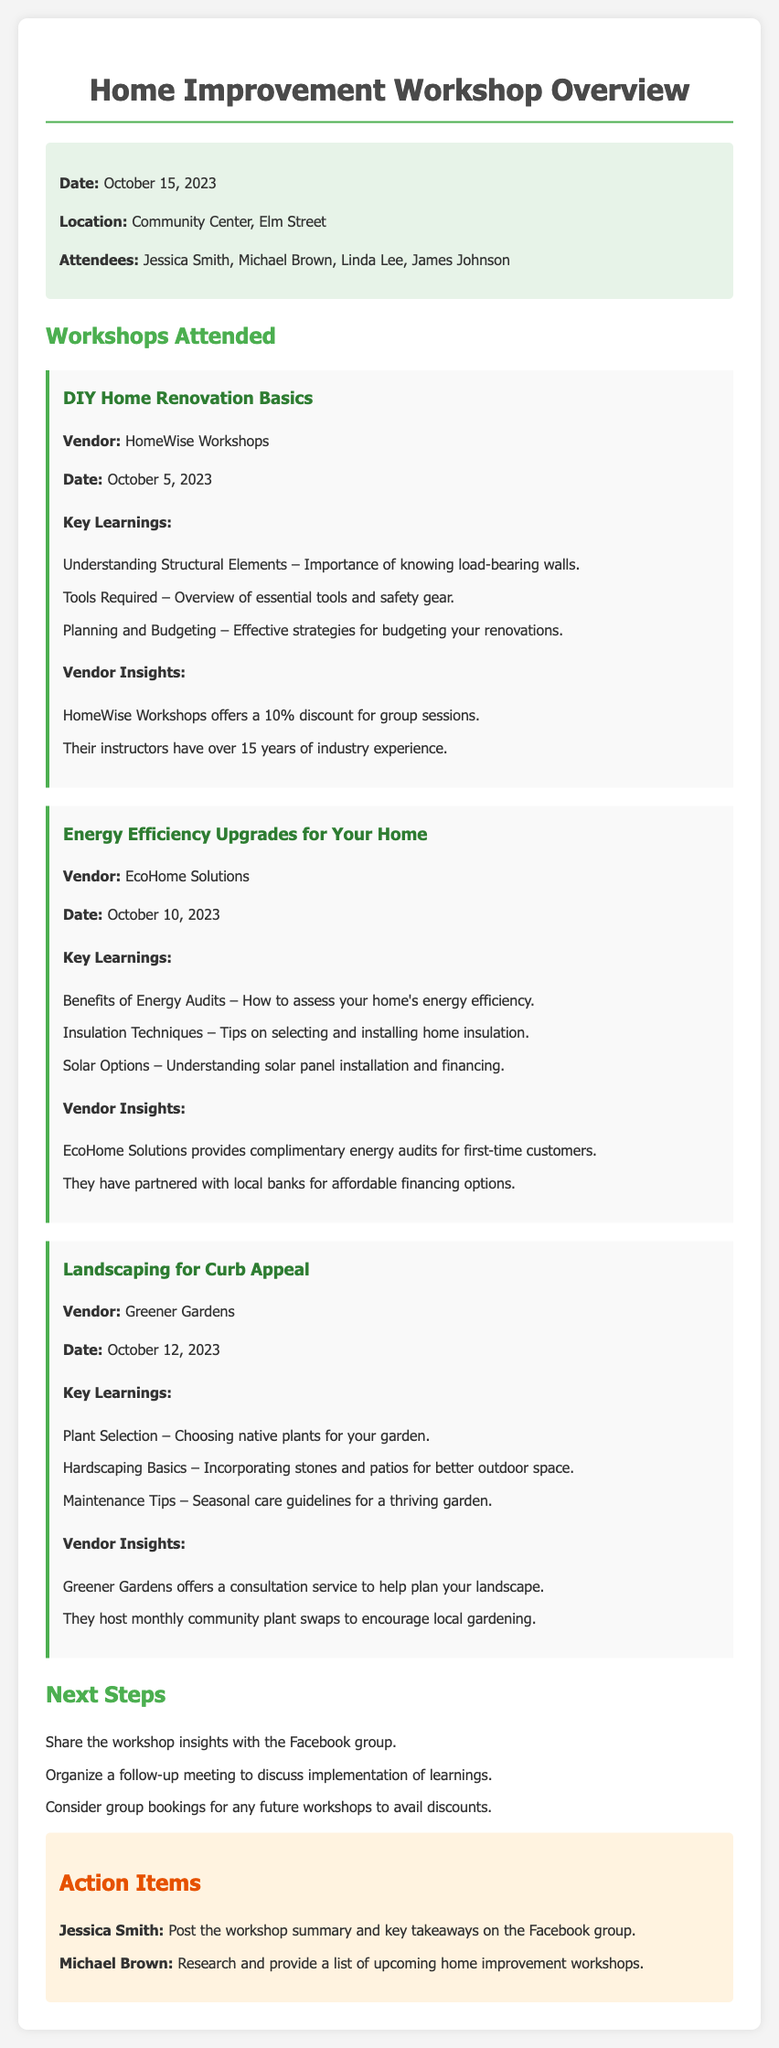what is the date of the workshop overview? The document states the workshop overview date as October 15, 2023.
Answer: October 15, 2023 who was the vendor for the DIY Home Renovation Basics workshop? The DIY Home Renovation Basics workshop was conducted by HomeWise Workshops.
Answer: HomeWise Workshops how many key learnings are listed for the Energy Efficiency Upgrades for Your Home workshop? The Energy Efficiency Upgrades for Your Home workshop lists three key learnings.
Answer: 3 what is one benefit of attending the Energy Efficiency Upgrades for Your Home workshop? One benefit is that EcoHome Solutions provides complimentary energy audits for first-time customers.
Answer: Complimentary energy audits which member is tasked with posting the workshop summary on Facebook? Jessica Smith is responsible for posting the workshop summary on the Facebook group.
Answer: Jessica Smith what type of plants are recommended in the Landscaping for Curb Appeal workshop? The workshop recommends choosing native plants for the garden.
Answer: Native plants how many workshops were attended according to the document? The document details three workshops attended by the members.
Answer: 3 what is one action item for Michael Brown? Michael Brown is tasked with researching and providing a list of upcoming home improvement workshops.
Answer: Research upcoming workshops 